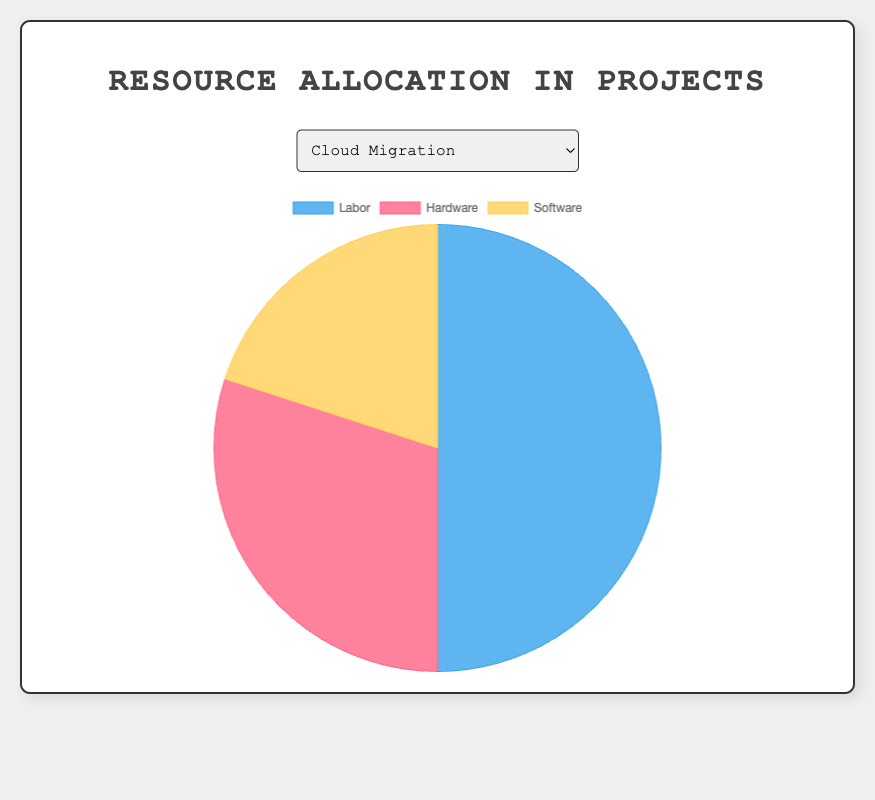What's the percentage allocation for Labor in the "ERP Implementation" project? By looking at the pie chart for the "ERP Implementation" project, the sectors will show that the Labor allocation is represented by 60%.
Answer: 60% Which project has the highest allocation for Software? We need to compare the Software percentages across all projects. The "Website Redesign" project allocates 50% to Software, which is higher than the other projects.
Answer: Website Redesign How much more is the labor allocation compared to hardware in the "CRM Integration" project? In the "CRM Integration" project, Labor is 55% and Hardware is 25%. The difference is 55% - 25% = 30%.
Answer: 30% What is the total percentage allocation for Software across all projects? Sum Software allocations: 20% (Cloud Migration) + 20% (ERP Implementation) + 50% (Website Redesign) + 20% (CRM Integration) + 20% (Cybersecurity Enhancement) = 130%. Average by 5 projects = 130%/5.
Answer: 26% Which project has the lowest allocation for Hardware? By comparing the Hardware percentages, "Website Redesign" has the lowest allocation at 10%.
Answer: Website Redesign Is the allocation for Hardware greater than Software in the "Cybersecurity Enhancement" project? The "Cybersecurity Enhancement" project has 35% for Hardware and 20% for Software, so Hardware > Software.
Answer: Yes What visual attribute distinguishes the Software sector in the pie charts? The Software sector in the pie charts is represented by the yellow color.
Answer: Yellow Compare the labor allocation of "Cloud Migration" and "Website Redesign". Which one is higher and by how much? "Cloud Migration" has a 50% labor allocation and "Website Redesign" has 40%. Difference is 50% - 40% = 10%. "Cloud Migration" is higher by 10%.
Answer: Cloud Migration by 10% What is the average allocation for Labor across all projects? Sum of Labor allocations: 50% (Cloud Migration) + 60% (ERP Implementation) + 40% (Website Redesign) + 55% (CRM Integration) + 45% (Cybersecurity Enhancement) = 250%. Average is 250% / 5 = 50%.
Answer: 50% 